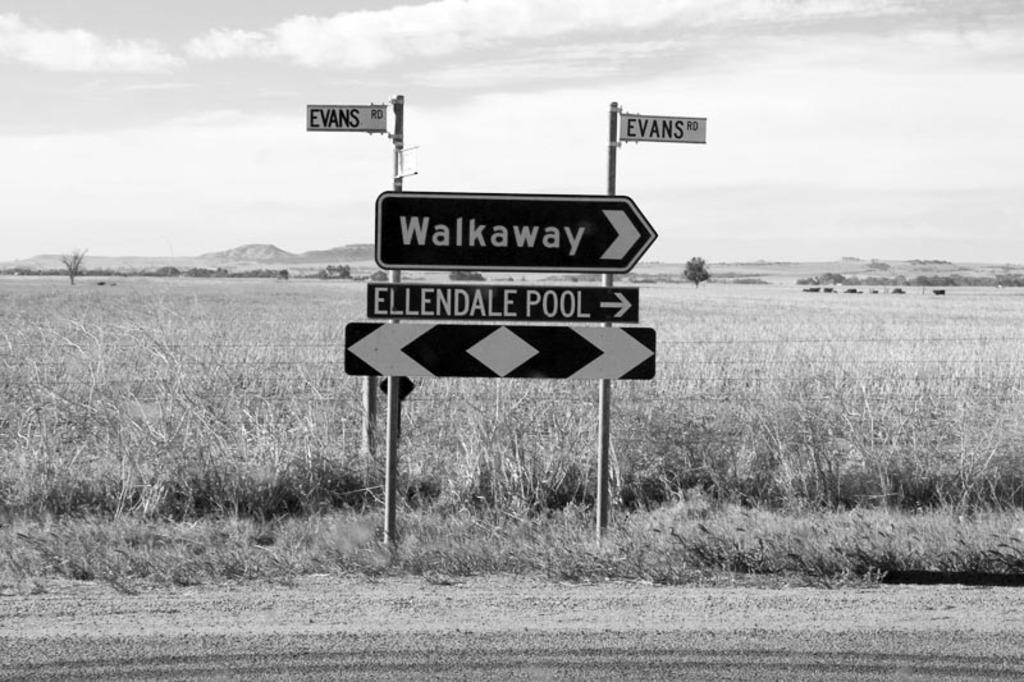What type of signs are present in the image? There are name directional boards in the image. What can be seen in the background of the image? There is grass and mountains visible in the background of the image. What type of coat is the mountain wearing in the image? There is no coat present in the image, as mountains do not wear clothing. 